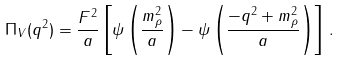<formula> <loc_0><loc_0><loc_500><loc_500>\Pi _ { V } ( q ^ { 2 } ) = \frac { F ^ { 2 } } { a } \left [ \psi \left ( \frac { m _ { \rho } ^ { 2 } } { a } \right ) - \psi \left ( \frac { - q ^ { 2 } + m _ { \rho } ^ { 2 } } { a } \right ) \right ] \, .</formula> 